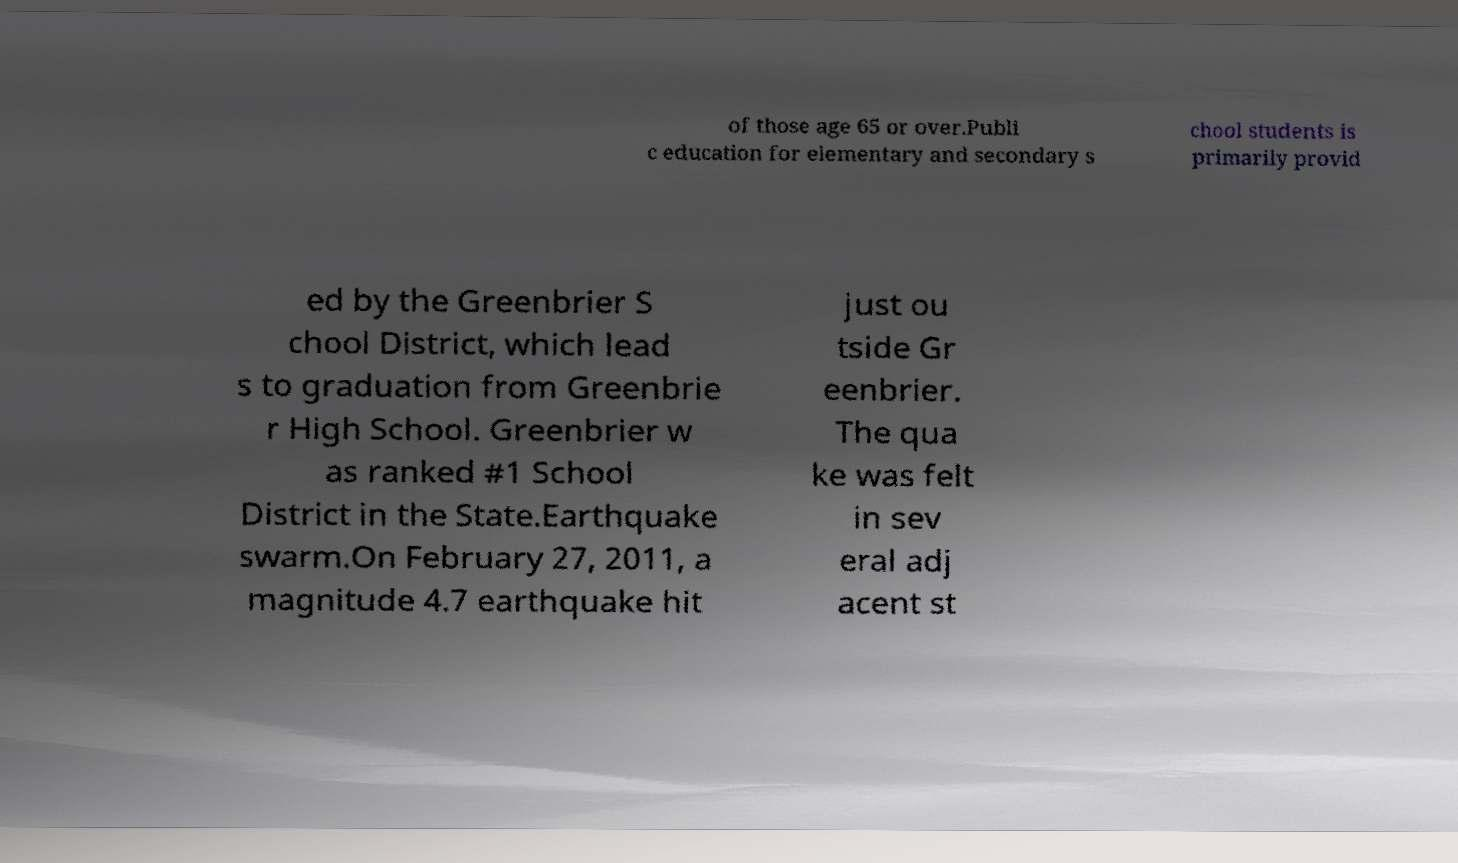Could you extract and type out the text from this image? of those age 65 or over.Publi c education for elementary and secondary s chool students is primarily provid ed by the Greenbrier S chool District, which lead s to graduation from Greenbrie r High School. Greenbrier w as ranked #1 School District in the State.Earthquake swarm.On February 27, 2011, a magnitude 4.7 earthquake hit just ou tside Gr eenbrier. The qua ke was felt in sev eral adj acent st 